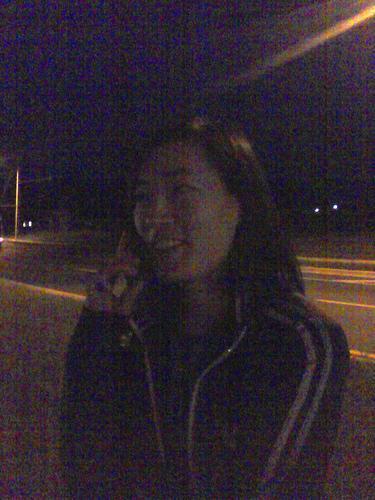How many people are in the photo?
Give a very brief answer. 1. 